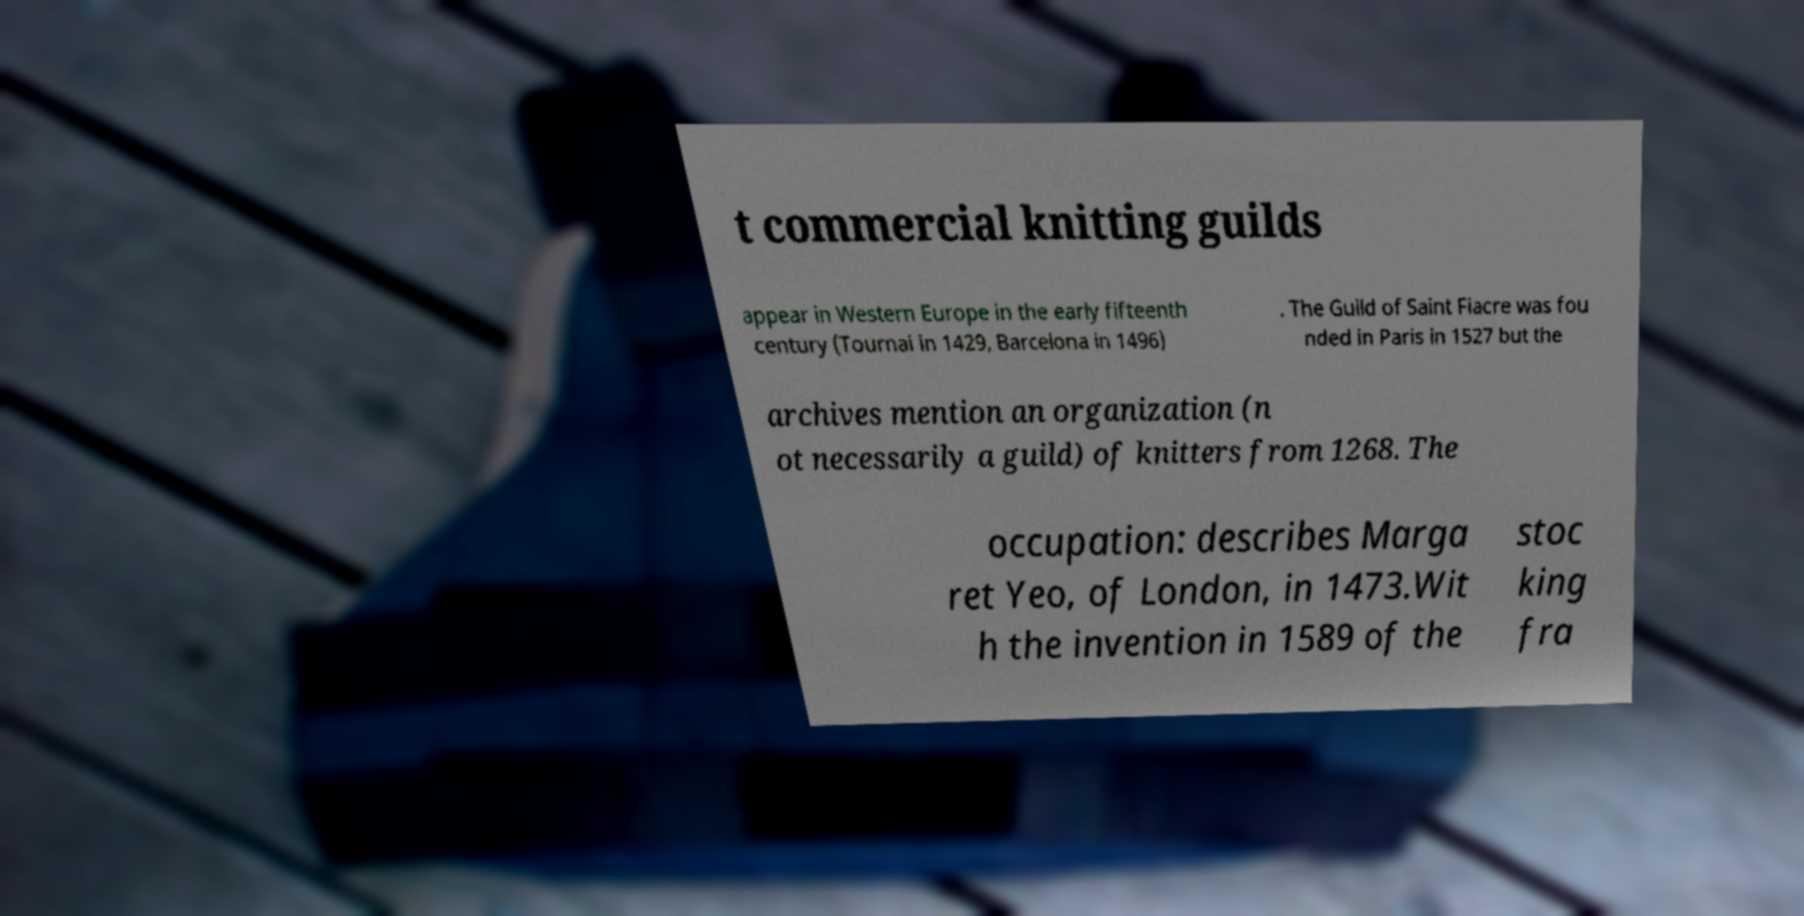There's text embedded in this image that I need extracted. Can you transcribe it verbatim? t commercial knitting guilds appear in Western Europe in the early fifteenth century (Tournai in 1429, Barcelona in 1496) . The Guild of Saint Fiacre was fou nded in Paris in 1527 but the archives mention an organization (n ot necessarily a guild) of knitters from 1268. The occupation: describes Marga ret Yeo, of London, in 1473.Wit h the invention in 1589 of the stoc king fra 